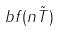<formula> <loc_0><loc_0><loc_500><loc_500>b f ( n \tilde { T } )</formula> 